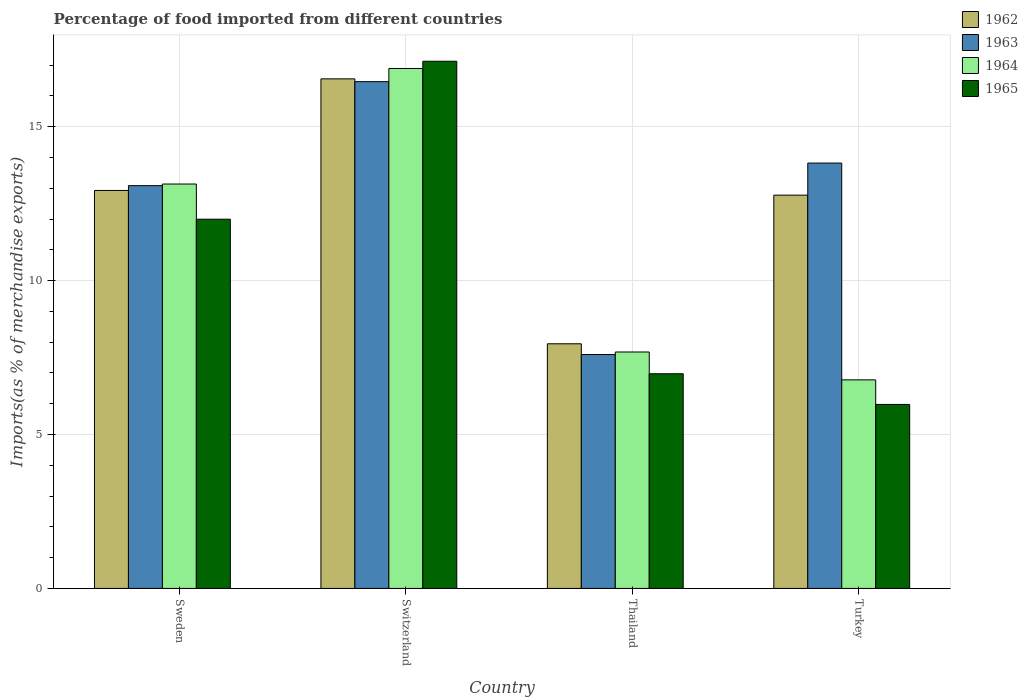How many groups of bars are there?
Offer a terse response. 4. What is the percentage of imports to different countries in 1964 in Switzerland?
Your answer should be very brief. 16.89. Across all countries, what is the maximum percentage of imports to different countries in 1962?
Give a very brief answer. 16.55. Across all countries, what is the minimum percentage of imports to different countries in 1962?
Offer a terse response. 7.95. In which country was the percentage of imports to different countries in 1963 maximum?
Your answer should be very brief. Switzerland. In which country was the percentage of imports to different countries in 1963 minimum?
Give a very brief answer. Thailand. What is the total percentage of imports to different countries in 1964 in the graph?
Offer a terse response. 44.48. What is the difference between the percentage of imports to different countries in 1962 in Sweden and that in Switzerland?
Your answer should be very brief. -3.63. What is the difference between the percentage of imports to different countries in 1964 in Turkey and the percentage of imports to different countries in 1962 in Thailand?
Your response must be concise. -1.17. What is the average percentage of imports to different countries in 1963 per country?
Offer a very short reply. 12.74. What is the difference between the percentage of imports to different countries of/in 1965 and percentage of imports to different countries of/in 1964 in Switzerland?
Your answer should be compact. 0.24. In how many countries, is the percentage of imports to different countries in 1963 greater than 8 %?
Provide a succinct answer. 3. What is the ratio of the percentage of imports to different countries in 1962 in Sweden to that in Thailand?
Provide a succinct answer. 1.63. Is the percentage of imports to different countries in 1963 in Switzerland less than that in Turkey?
Your answer should be compact. No. What is the difference between the highest and the second highest percentage of imports to different countries in 1965?
Provide a succinct answer. 5.13. What is the difference between the highest and the lowest percentage of imports to different countries in 1964?
Provide a succinct answer. 10.11. In how many countries, is the percentage of imports to different countries in 1962 greater than the average percentage of imports to different countries in 1962 taken over all countries?
Your answer should be compact. 3. Is it the case that in every country, the sum of the percentage of imports to different countries in 1962 and percentage of imports to different countries in 1964 is greater than the sum of percentage of imports to different countries in 1963 and percentage of imports to different countries in 1965?
Give a very brief answer. No. What does the 3rd bar from the left in Thailand represents?
Your answer should be very brief. 1964. What does the 2nd bar from the right in Thailand represents?
Provide a succinct answer. 1964. Is it the case that in every country, the sum of the percentage of imports to different countries in 1965 and percentage of imports to different countries in 1962 is greater than the percentage of imports to different countries in 1963?
Ensure brevity in your answer.  Yes. How many bars are there?
Keep it short and to the point. 16. Are all the bars in the graph horizontal?
Provide a succinct answer. No. How many countries are there in the graph?
Keep it short and to the point. 4. What is the difference between two consecutive major ticks on the Y-axis?
Ensure brevity in your answer.  5. Are the values on the major ticks of Y-axis written in scientific E-notation?
Provide a succinct answer. No. Does the graph contain any zero values?
Offer a very short reply. No. Does the graph contain grids?
Ensure brevity in your answer.  Yes. Where does the legend appear in the graph?
Your response must be concise. Top right. How are the legend labels stacked?
Make the answer very short. Vertical. What is the title of the graph?
Provide a short and direct response. Percentage of food imported from different countries. What is the label or title of the X-axis?
Your response must be concise. Country. What is the label or title of the Y-axis?
Ensure brevity in your answer.  Imports(as % of merchandise exports). What is the Imports(as % of merchandise exports) of 1962 in Sweden?
Provide a short and direct response. 12.93. What is the Imports(as % of merchandise exports) in 1963 in Sweden?
Your answer should be very brief. 13.08. What is the Imports(as % of merchandise exports) in 1964 in Sweden?
Give a very brief answer. 13.14. What is the Imports(as % of merchandise exports) in 1965 in Sweden?
Ensure brevity in your answer.  11.99. What is the Imports(as % of merchandise exports) of 1962 in Switzerland?
Offer a very short reply. 16.55. What is the Imports(as % of merchandise exports) in 1963 in Switzerland?
Make the answer very short. 16.46. What is the Imports(as % of merchandise exports) in 1964 in Switzerland?
Provide a succinct answer. 16.89. What is the Imports(as % of merchandise exports) of 1965 in Switzerland?
Your answer should be compact. 17.12. What is the Imports(as % of merchandise exports) in 1962 in Thailand?
Give a very brief answer. 7.95. What is the Imports(as % of merchandise exports) of 1963 in Thailand?
Offer a terse response. 7.6. What is the Imports(as % of merchandise exports) of 1964 in Thailand?
Your answer should be compact. 7.68. What is the Imports(as % of merchandise exports) in 1965 in Thailand?
Provide a succinct answer. 6.97. What is the Imports(as % of merchandise exports) in 1962 in Turkey?
Your response must be concise. 12.77. What is the Imports(as % of merchandise exports) in 1963 in Turkey?
Offer a terse response. 13.82. What is the Imports(as % of merchandise exports) of 1964 in Turkey?
Provide a short and direct response. 6.77. What is the Imports(as % of merchandise exports) of 1965 in Turkey?
Make the answer very short. 5.98. Across all countries, what is the maximum Imports(as % of merchandise exports) in 1962?
Keep it short and to the point. 16.55. Across all countries, what is the maximum Imports(as % of merchandise exports) of 1963?
Provide a short and direct response. 16.46. Across all countries, what is the maximum Imports(as % of merchandise exports) of 1964?
Make the answer very short. 16.89. Across all countries, what is the maximum Imports(as % of merchandise exports) of 1965?
Provide a succinct answer. 17.12. Across all countries, what is the minimum Imports(as % of merchandise exports) in 1962?
Your response must be concise. 7.95. Across all countries, what is the minimum Imports(as % of merchandise exports) in 1963?
Keep it short and to the point. 7.6. Across all countries, what is the minimum Imports(as % of merchandise exports) of 1964?
Your answer should be very brief. 6.77. Across all countries, what is the minimum Imports(as % of merchandise exports) in 1965?
Your response must be concise. 5.98. What is the total Imports(as % of merchandise exports) in 1962 in the graph?
Your answer should be very brief. 50.2. What is the total Imports(as % of merchandise exports) in 1963 in the graph?
Provide a short and direct response. 50.96. What is the total Imports(as % of merchandise exports) in 1964 in the graph?
Keep it short and to the point. 44.48. What is the total Imports(as % of merchandise exports) in 1965 in the graph?
Provide a short and direct response. 42.07. What is the difference between the Imports(as % of merchandise exports) of 1962 in Sweden and that in Switzerland?
Offer a terse response. -3.63. What is the difference between the Imports(as % of merchandise exports) in 1963 in Sweden and that in Switzerland?
Offer a very short reply. -3.38. What is the difference between the Imports(as % of merchandise exports) of 1964 in Sweden and that in Switzerland?
Your answer should be compact. -3.75. What is the difference between the Imports(as % of merchandise exports) in 1965 in Sweden and that in Switzerland?
Offer a terse response. -5.13. What is the difference between the Imports(as % of merchandise exports) of 1962 in Sweden and that in Thailand?
Provide a succinct answer. 4.98. What is the difference between the Imports(as % of merchandise exports) of 1963 in Sweden and that in Thailand?
Make the answer very short. 5.49. What is the difference between the Imports(as % of merchandise exports) in 1964 in Sweden and that in Thailand?
Make the answer very short. 5.46. What is the difference between the Imports(as % of merchandise exports) of 1965 in Sweden and that in Thailand?
Provide a short and direct response. 5.02. What is the difference between the Imports(as % of merchandise exports) in 1962 in Sweden and that in Turkey?
Your answer should be compact. 0.15. What is the difference between the Imports(as % of merchandise exports) in 1963 in Sweden and that in Turkey?
Your answer should be very brief. -0.73. What is the difference between the Imports(as % of merchandise exports) of 1964 in Sweden and that in Turkey?
Make the answer very short. 6.36. What is the difference between the Imports(as % of merchandise exports) in 1965 in Sweden and that in Turkey?
Your response must be concise. 6.02. What is the difference between the Imports(as % of merchandise exports) of 1962 in Switzerland and that in Thailand?
Make the answer very short. 8.61. What is the difference between the Imports(as % of merchandise exports) of 1963 in Switzerland and that in Thailand?
Keep it short and to the point. 8.86. What is the difference between the Imports(as % of merchandise exports) in 1964 in Switzerland and that in Thailand?
Your response must be concise. 9.21. What is the difference between the Imports(as % of merchandise exports) of 1965 in Switzerland and that in Thailand?
Offer a very short reply. 10.15. What is the difference between the Imports(as % of merchandise exports) in 1962 in Switzerland and that in Turkey?
Offer a very short reply. 3.78. What is the difference between the Imports(as % of merchandise exports) in 1963 in Switzerland and that in Turkey?
Your answer should be very brief. 2.64. What is the difference between the Imports(as % of merchandise exports) of 1964 in Switzerland and that in Turkey?
Keep it short and to the point. 10.11. What is the difference between the Imports(as % of merchandise exports) in 1965 in Switzerland and that in Turkey?
Give a very brief answer. 11.15. What is the difference between the Imports(as % of merchandise exports) in 1962 in Thailand and that in Turkey?
Offer a terse response. -4.83. What is the difference between the Imports(as % of merchandise exports) in 1963 in Thailand and that in Turkey?
Make the answer very short. -6.22. What is the difference between the Imports(as % of merchandise exports) in 1964 in Thailand and that in Turkey?
Ensure brevity in your answer.  0.91. What is the difference between the Imports(as % of merchandise exports) of 1962 in Sweden and the Imports(as % of merchandise exports) of 1963 in Switzerland?
Provide a short and direct response. -3.53. What is the difference between the Imports(as % of merchandise exports) in 1962 in Sweden and the Imports(as % of merchandise exports) in 1964 in Switzerland?
Provide a short and direct response. -3.96. What is the difference between the Imports(as % of merchandise exports) of 1962 in Sweden and the Imports(as % of merchandise exports) of 1965 in Switzerland?
Make the answer very short. -4.2. What is the difference between the Imports(as % of merchandise exports) of 1963 in Sweden and the Imports(as % of merchandise exports) of 1964 in Switzerland?
Ensure brevity in your answer.  -3.81. What is the difference between the Imports(as % of merchandise exports) of 1963 in Sweden and the Imports(as % of merchandise exports) of 1965 in Switzerland?
Your answer should be compact. -4.04. What is the difference between the Imports(as % of merchandise exports) in 1964 in Sweden and the Imports(as % of merchandise exports) in 1965 in Switzerland?
Your answer should be compact. -3.99. What is the difference between the Imports(as % of merchandise exports) of 1962 in Sweden and the Imports(as % of merchandise exports) of 1963 in Thailand?
Your answer should be very brief. 5.33. What is the difference between the Imports(as % of merchandise exports) of 1962 in Sweden and the Imports(as % of merchandise exports) of 1964 in Thailand?
Your answer should be very brief. 5.25. What is the difference between the Imports(as % of merchandise exports) in 1962 in Sweden and the Imports(as % of merchandise exports) in 1965 in Thailand?
Ensure brevity in your answer.  5.95. What is the difference between the Imports(as % of merchandise exports) of 1963 in Sweden and the Imports(as % of merchandise exports) of 1964 in Thailand?
Your answer should be compact. 5.4. What is the difference between the Imports(as % of merchandise exports) in 1963 in Sweden and the Imports(as % of merchandise exports) in 1965 in Thailand?
Provide a short and direct response. 6.11. What is the difference between the Imports(as % of merchandise exports) of 1964 in Sweden and the Imports(as % of merchandise exports) of 1965 in Thailand?
Offer a very short reply. 6.16. What is the difference between the Imports(as % of merchandise exports) of 1962 in Sweden and the Imports(as % of merchandise exports) of 1963 in Turkey?
Your response must be concise. -0.89. What is the difference between the Imports(as % of merchandise exports) of 1962 in Sweden and the Imports(as % of merchandise exports) of 1964 in Turkey?
Make the answer very short. 6.15. What is the difference between the Imports(as % of merchandise exports) of 1962 in Sweden and the Imports(as % of merchandise exports) of 1965 in Turkey?
Provide a short and direct response. 6.95. What is the difference between the Imports(as % of merchandise exports) of 1963 in Sweden and the Imports(as % of merchandise exports) of 1964 in Turkey?
Ensure brevity in your answer.  6.31. What is the difference between the Imports(as % of merchandise exports) in 1963 in Sweden and the Imports(as % of merchandise exports) in 1965 in Turkey?
Your answer should be very brief. 7.11. What is the difference between the Imports(as % of merchandise exports) in 1964 in Sweden and the Imports(as % of merchandise exports) in 1965 in Turkey?
Provide a short and direct response. 7.16. What is the difference between the Imports(as % of merchandise exports) of 1962 in Switzerland and the Imports(as % of merchandise exports) of 1963 in Thailand?
Your answer should be compact. 8.96. What is the difference between the Imports(as % of merchandise exports) of 1962 in Switzerland and the Imports(as % of merchandise exports) of 1964 in Thailand?
Offer a terse response. 8.87. What is the difference between the Imports(as % of merchandise exports) of 1962 in Switzerland and the Imports(as % of merchandise exports) of 1965 in Thailand?
Make the answer very short. 9.58. What is the difference between the Imports(as % of merchandise exports) in 1963 in Switzerland and the Imports(as % of merchandise exports) in 1964 in Thailand?
Offer a terse response. 8.78. What is the difference between the Imports(as % of merchandise exports) of 1963 in Switzerland and the Imports(as % of merchandise exports) of 1965 in Thailand?
Your answer should be very brief. 9.49. What is the difference between the Imports(as % of merchandise exports) of 1964 in Switzerland and the Imports(as % of merchandise exports) of 1965 in Thailand?
Provide a short and direct response. 9.92. What is the difference between the Imports(as % of merchandise exports) of 1962 in Switzerland and the Imports(as % of merchandise exports) of 1963 in Turkey?
Ensure brevity in your answer.  2.74. What is the difference between the Imports(as % of merchandise exports) in 1962 in Switzerland and the Imports(as % of merchandise exports) in 1964 in Turkey?
Provide a short and direct response. 9.78. What is the difference between the Imports(as % of merchandise exports) of 1962 in Switzerland and the Imports(as % of merchandise exports) of 1965 in Turkey?
Your answer should be very brief. 10.58. What is the difference between the Imports(as % of merchandise exports) of 1963 in Switzerland and the Imports(as % of merchandise exports) of 1964 in Turkey?
Give a very brief answer. 9.69. What is the difference between the Imports(as % of merchandise exports) of 1963 in Switzerland and the Imports(as % of merchandise exports) of 1965 in Turkey?
Your answer should be very brief. 10.48. What is the difference between the Imports(as % of merchandise exports) in 1964 in Switzerland and the Imports(as % of merchandise exports) in 1965 in Turkey?
Offer a terse response. 10.91. What is the difference between the Imports(as % of merchandise exports) in 1962 in Thailand and the Imports(as % of merchandise exports) in 1963 in Turkey?
Your answer should be compact. -5.87. What is the difference between the Imports(as % of merchandise exports) in 1962 in Thailand and the Imports(as % of merchandise exports) in 1964 in Turkey?
Your response must be concise. 1.17. What is the difference between the Imports(as % of merchandise exports) in 1962 in Thailand and the Imports(as % of merchandise exports) in 1965 in Turkey?
Your answer should be compact. 1.97. What is the difference between the Imports(as % of merchandise exports) in 1963 in Thailand and the Imports(as % of merchandise exports) in 1964 in Turkey?
Your answer should be compact. 0.82. What is the difference between the Imports(as % of merchandise exports) in 1963 in Thailand and the Imports(as % of merchandise exports) in 1965 in Turkey?
Provide a succinct answer. 1.62. What is the difference between the Imports(as % of merchandise exports) in 1964 in Thailand and the Imports(as % of merchandise exports) in 1965 in Turkey?
Your answer should be compact. 1.7. What is the average Imports(as % of merchandise exports) in 1962 per country?
Offer a very short reply. 12.55. What is the average Imports(as % of merchandise exports) in 1963 per country?
Make the answer very short. 12.74. What is the average Imports(as % of merchandise exports) of 1964 per country?
Ensure brevity in your answer.  11.12. What is the average Imports(as % of merchandise exports) in 1965 per country?
Offer a terse response. 10.52. What is the difference between the Imports(as % of merchandise exports) of 1962 and Imports(as % of merchandise exports) of 1963 in Sweden?
Your answer should be compact. -0.16. What is the difference between the Imports(as % of merchandise exports) of 1962 and Imports(as % of merchandise exports) of 1964 in Sweden?
Your answer should be very brief. -0.21. What is the difference between the Imports(as % of merchandise exports) in 1962 and Imports(as % of merchandise exports) in 1965 in Sweden?
Your answer should be very brief. 0.93. What is the difference between the Imports(as % of merchandise exports) of 1963 and Imports(as % of merchandise exports) of 1964 in Sweden?
Provide a short and direct response. -0.05. What is the difference between the Imports(as % of merchandise exports) in 1963 and Imports(as % of merchandise exports) in 1965 in Sweden?
Your answer should be very brief. 1.09. What is the difference between the Imports(as % of merchandise exports) of 1964 and Imports(as % of merchandise exports) of 1965 in Sweden?
Your response must be concise. 1.14. What is the difference between the Imports(as % of merchandise exports) of 1962 and Imports(as % of merchandise exports) of 1963 in Switzerland?
Provide a succinct answer. 0.09. What is the difference between the Imports(as % of merchandise exports) of 1962 and Imports(as % of merchandise exports) of 1964 in Switzerland?
Ensure brevity in your answer.  -0.34. What is the difference between the Imports(as % of merchandise exports) of 1962 and Imports(as % of merchandise exports) of 1965 in Switzerland?
Provide a succinct answer. -0.57. What is the difference between the Imports(as % of merchandise exports) in 1963 and Imports(as % of merchandise exports) in 1964 in Switzerland?
Your answer should be compact. -0.43. What is the difference between the Imports(as % of merchandise exports) in 1963 and Imports(as % of merchandise exports) in 1965 in Switzerland?
Keep it short and to the point. -0.66. What is the difference between the Imports(as % of merchandise exports) in 1964 and Imports(as % of merchandise exports) in 1965 in Switzerland?
Your answer should be very brief. -0.24. What is the difference between the Imports(as % of merchandise exports) of 1962 and Imports(as % of merchandise exports) of 1963 in Thailand?
Your response must be concise. 0.35. What is the difference between the Imports(as % of merchandise exports) in 1962 and Imports(as % of merchandise exports) in 1964 in Thailand?
Your answer should be compact. 0.27. What is the difference between the Imports(as % of merchandise exports) of 1962 and Imports(as % of merchandise exports) of 1965 in Thailand?
Your answer should be compact. 0.97. What is the difference between the Imports(as % of merchandise exports) of 1963 and Imports(as % of merchandise exports) of 1964 in Thailand?
Give a very brief answer. -0.08. What is the difference between the Imports(as % of merchandise exports) of 1963 and Imports(as % of merchandise exports) of 1965 in Thailand?
Your answer should be compact. 0.62. What is the difference between the Imports(as % of merchandise exports) in 1964 and Imports(as % of merchandise exports) in 1965 in Thailand?
Make the answer very short. 0.71. What is the difference between the Imports(as % of merchandise exports) in 1962 and Imports(as % of merchandise exports) in 1963 in Turkey?
Offer a very short reply. -1.04. What is the difference between the Imports(as % of merchandise exports) of 1962 and Imports(as % of merchandise exports) of 1964 in Turkey?
Offer a terse response. 6. What is the difference between the Imports(as % of merchandise exports) of 1962 and Imports(as % of merchandise exports) of 1965 in Turkey?
Your answer should be compact. 6.8. What is the difference between the Imports(as % of merchandise exports) of 1963 and Imports(as % of merchandise exports) of 1964 in Turkey?
Provide a short and direct response. 7.04. What is the difference between the Imports(as % of merchandise exports) of 1963 and Imports(as % of merchandise exports) of 1965 in Turkey?
Your answer should be compact. 7.84. What is the difference between the Imports(as % of merchandise exports) of 1964 and Imports(as % of merchandise exports) of 1965 in Turkey?
Your answer should be very brief. 0.8. What is the ratio of the Imports(as % of merchandise exports) of 1962 in Sweden to that in Switzerland?
Ensure brevity in your answer.  0.78. What is the ratio of the Imports(as % of merchandise exports) of 1963 in Sweden to that in Switzerland?
Offer a very short reply. 0.79. What is the ratio of the Imports(as % of merchandise exports) in 1965 in Sweden to that in Switzerland?
Offer a very short reply. 0.7. What is the ratio of the Imports(as % of merchandise exports) of 1962 in Sweden to that in Thailand?
Ensure brevity in your answer.  1.63. What is the ratio of the Imports(as % of merchandise exports) of 1963 in Sweden to that in Thailand?
Your answer should be very brief. 1.72. What is the ratio of the Imports(as % of merchandise exports) of 1964 in Sweden to that in Thailand?
Offer a very short reply. 1.71. What is the ratio of the Imports(as % of merchandise exports) in 1965 in Sweden to that in Thailand?
Give a very brief answer. 1.72. What is the ratio of the Imports(as % of merchandise exports) of 1962 in Sweden to that in Turkey?
Make the answer very short. 1.01. What is the ratio of the Imports(as % of merchandise exports) of 1963 in Sweden to that in Turkey?
Your answer should be very brief. 0.95. What is the ratio of the Imports(as % of merchandise exports) of 1964 in Sweden to that in Turkey?
Offer a terse response. 1.94. What is the ratio of the Imports(as % of merchandise exports) in 1965 in Sweden to that in Turkey?
Your answer should be compact. 2.01. What is the ratio of the Imports(as % of merchandise exports) in 1962 in Switzerland to that in Thailand?
Make the answer very short. 2.08. What is the ratio of the Imports(as % of merchandise exports) in 1963 in Switzerland to that in Thailand?
Your answer should be very brief. 2.17. What is the ratio of the Imports(as % of merchandise exports) of 1964 in Switzerland to that in Thailand?
Offer a terse response. 2.2. What is the ratio of the Imports(as % of merchandise exports) in 1965 in Switzerland to that in Thailand?
Provide a short and direct response. 2.46. What is the ratio of the Imports(as % of merchandise exports) in 1962 in Switzerland to that in Turkey?
Provide a short and direct response. 1.3. What is the ratio of the Imports(as % of merchandise exports) of 1963 in Switzerland to that in Turkey?
Your response must be concise. 1.19. What is the ratio of the Imports(as % of merchandise exports) in 1964 in Switzerland to that in Turkey?
Ensure brevity in your answer.  2.49. What is the ratio of the Imports(as % of merchandise exports) of 1965 in Switzerland to that in Turkey?
Give a very brief answer. 2.87. What is the ratio of the Imports(as % of merchandise exports) in 1962 in Thailand to that in Turkey?
Your response must be concise. 0.62. What is the ratio of the Imports(as % of merchandise exports) of 1963 in Thailand to that in Turkey?
Ensure brevity in your answer.  0.55. What is the ratio of the Imports(as % of merchandise exports) of 1964 in Thailand to that in Turkey?
Your answer should be very brief. 1.13. What is the ratio of the Imports(as % of merchandise exports) of 1965 in Thailand to that in Turkey?
Give a very brief answer. 1.17. What is the difference between the highest and the second highest Imports(as % of merchandise exports) of 1962?
Offer a terse response. 3.63. What is the difference between the highest and the second highest Imports(as % of merchandise exports) of 1963?
Your answer should be very brief. 2.64. What is the difference between the highest and the second highest Imports(as % of merchandise exports) of 1964?
Offer a terse response. 3.75. What is the difference between the highest and the second highest Imports(as % of merchandise exports) in 1965?
Your answer should be very brief. 5.13. What is the difference between the highest and the lowest Imports(as % of merchandise exports) of 1962?
Keep it short and to the point. 8.61. What is the difference between the highest and the lowest Imports(as % of merchandise exports) of 1963?
Your response must be concise. 8.86. What is the difference between the highest and the lowest Imports(as % of merchandise exports) of 1964?
Your response must be concise. 10.11. What is the difference between the highest and the lowest Imports(as % of merchandise exports) in 1965?
Provide a short and direct response. 11.15. 